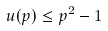<formula> <loc_0><loc_0><loc_500><loc_500>u ( p ) \leq p ^ { 2 } - 1</formula> 